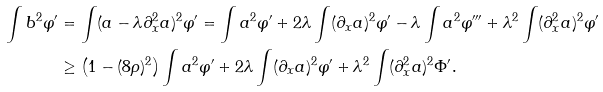<formula> <loc_0><loc_0><loc_500><loc_500>\int b ^ { 2 } \varphi ^ { \prime } & = \int ( a - \lambda \partial _ { x } ^ { 2 } a ) ^ { 2 } \varphi ^ { \prime } = \int a ^ { 2 } \varphi ^ { \prime } + 2 \lambda \int ( \partial _ { x } a ) ^ { 2 } \varphi ^ { \prime } - \lambda \int a ^ { 2 } \varphi ^ { \prime \prime \prime } + \lambda ^ { 2 } \int ( \partial _ { x } ^ { 2 } a ) ^ { 2 } \varphi ^ { \prime } \\ & \geq \left ( 1 - ( 8 \rho ) ^ { 2 } \right ) \int a ^ { 2 } \varphi ^ { \prime } + 2 \lambda \int ( \partial _ { x } a ) ^ { 2 } \varphi ^ { \prime } + \lambda ^ { 2 } \int ( \partial _ { x } ^ { 2 } a ) ^ { 2 } \Phi ^ { \prime } .</formula> 